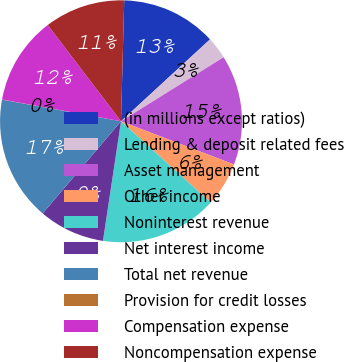<chart> <loc_0><loc_0><loc_500><loc_500><pie_chart><fcel>(in millions except ratios)<fcel>Lending & deposit related fees<fcel>Asset management<fcel>Other income<fcel>Noninterest revenue<fcel>Net interest income<fcel>Total net revenue<fcel>Provision for credit losses<fcel>Compensation expense<fcel>Noncompensation expense<nl><fcel>12.74%<fcel>2.96%<fcel>14.69%<fcel>5.9%<fcel>15.67%<fcel>8.83%<fcel>16.64%<fcel>0.03%<fcel>11.76%<fcel>10.78%<nl></chart> 